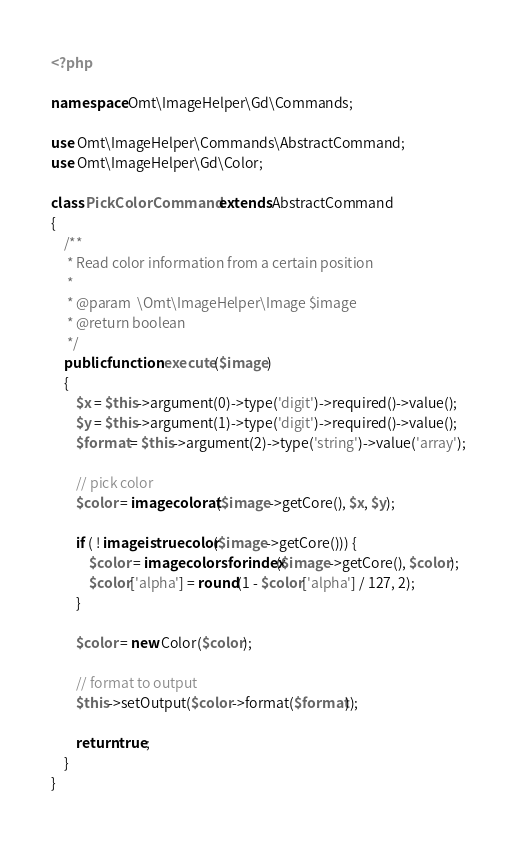Convert code to text. <code><loc_0><loc_0><loc_500><loc_500><_PHP_><?php

namespace Omt\ImageHelper\Gd\Commands;

use Omt\ImageHelper\Commands\AbstractCommand;
use Omt\ImageHelper\Gd\Color;

class PickColorCommand extends AbstractCommand
{
    /**
     * Read color information from a certain position
     *
     * @param  \Omt\ImageHelper\Image $image
     * @return boolean
     */
    public function execute($image)
    {
        $x = $this->argument(0)->type('digit')->required()->value();
        $y = $this->argument(1)->type('digit')->required()->value();
        $format = $this->argument(2)->type('string')->value('array');

        // pick color
        $color = imagecolorat($image->getCore(), $x, $y);

        if ( ! imageistruecolor($image->getCore())) {
            $color = imagecolorsforindex($image->getCore(), $color);
            $color['alpha'] = round(1 - $color['alpha'] / 127, 2);
        }

        $color = new Color($color);

        // format to output
        $this->setOutput($color->format($format));

        return true;
    }
}
</code> 